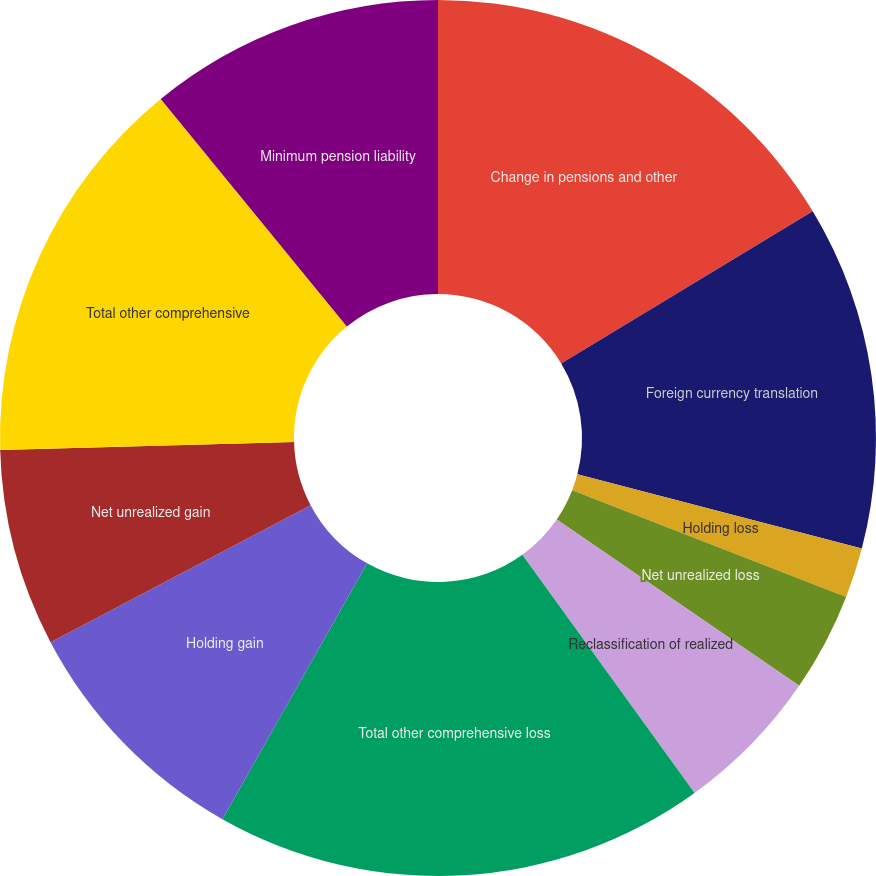<chart> <loc_0><loc_0><loc_500><loc_500><pie_chart><fcel>Change in pensions and other<fcel>Foreign currency translation<fcel>Holding loss<fcel>Net unrealized loss<fcel>Reclassification of realized<fcel>Total other comprehensive loss<fcel>Holding gain<fcel>Net unrealized gain<fcel>Total other comprehensive<fcel>Minimum pension liability<nl><fcel>16.34%<fcel>12.72%<fcel>1.85%<fcel>3.66%<fcel>5.47%<fcel>18.15%<fcel>9.09%<fcel>7.28%<fcel>14.53%<fcel>10.91%<nl></chart> 